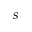Convert formula to latex. <formula><loc_0><loc_0><loc_500><loc_500>s</formula> 